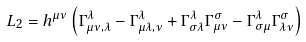Convert formula to latex. <formula><loc_0><loc_0><loc_500><loc_500>L _ { 2 } = h ^ { \mu \nu } \left ( \Gamma _ { \mu \nu , \lambda } ^ { \lambda } - \Gamma _ { \mu \lambda , \nu } ^ { \lambda } + \Gamma _ { \sigma \lambda } ^ { \lambda } \Gamma _ { \mu \nu } ^ { \sigma } - \Gamma _ { \sigma \mu } ^ { \lambda } \Gamma _ { \lambda \nu } ^ { \sigma } \right )</formula> 